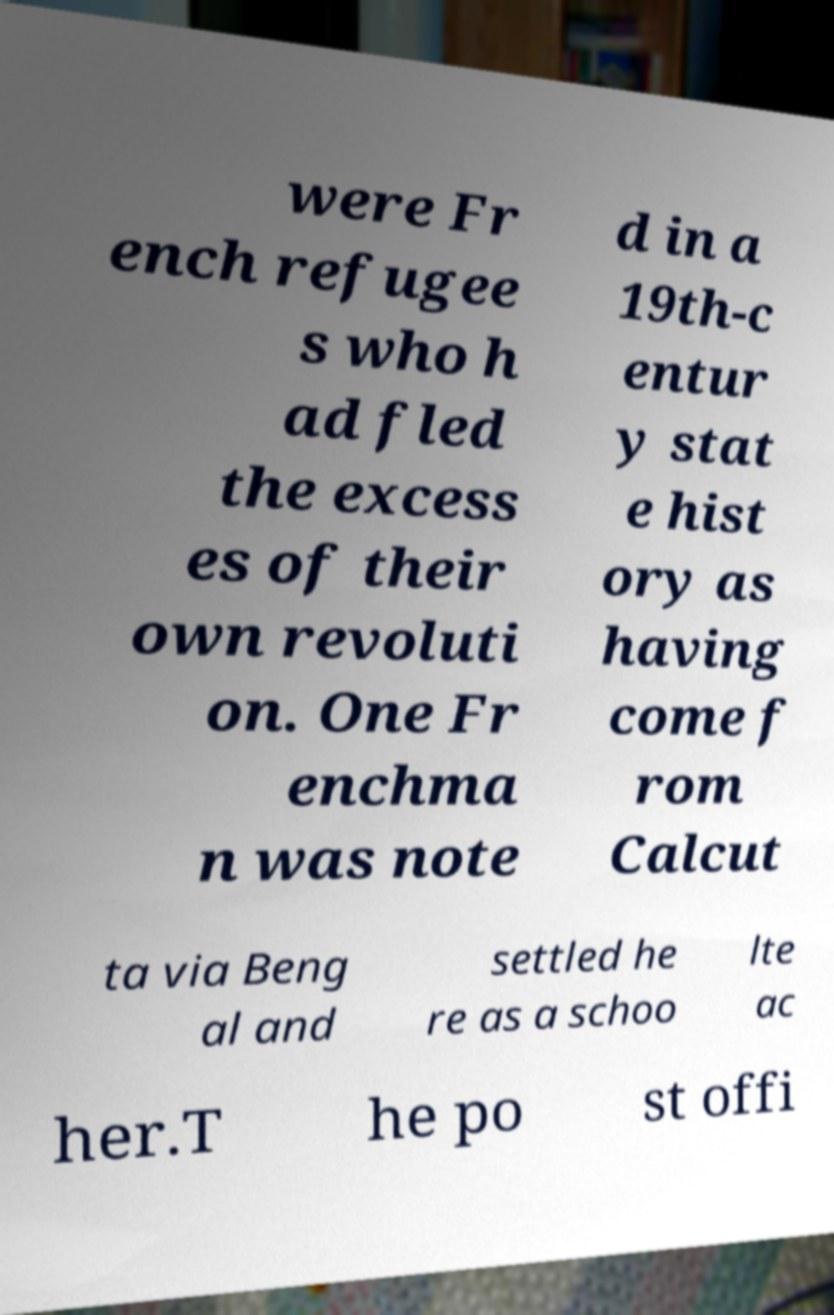I need the written content from this picture converted into text. Can you do that? were Fr ench refugee s who h ad fled the excess es of their own revoluti on. One Fr enchma n was note d in a 19th-c entur y stat e hist ory as having come f rom Calcut ta via Beng al and settled he re as a schoo lte ac her.T he po st offi 